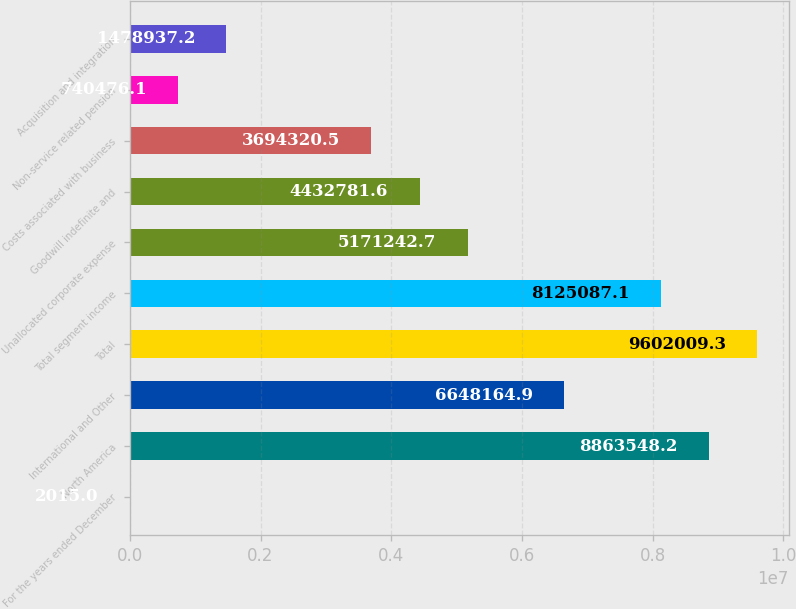Convert chart. <chart><loc_0><loc_0><loc_500><loc_500><bar_chart><fcel>For the years ended December<fcel>North America<fcel>International and Other<fcel>Total<fcel>Total segment income<fcel>Unallocated corporate expense<fcel>Goodwill indefinite and<fcel>Costs associated with business<fcel>Non-service related pension<fcel>Acquisition and integration<nl><fcel>2015<fcel>8.86355e+06<fcel>6.64816e+06<fcel>9.60201e+06<fcel>8.12509e+06<fcel>5.17124e+06<fcel>4.43278e+06<fcel>3.69432e+06<fcel>740476<fcel>1.47894e+06<nl></chart> 